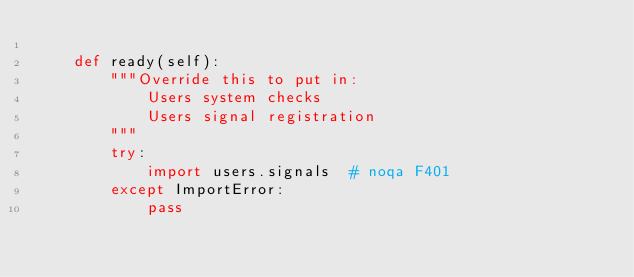Convert code to text. <code><loc_0><loc_0><loc_500><loc_500><_Python_>
    def ready(self):
        """Override this to put in:
            Users system checks
            Users signal registration
        """
        try:
            import users.signals  # noqa F401
        except ImportError:
            pass
</code> 